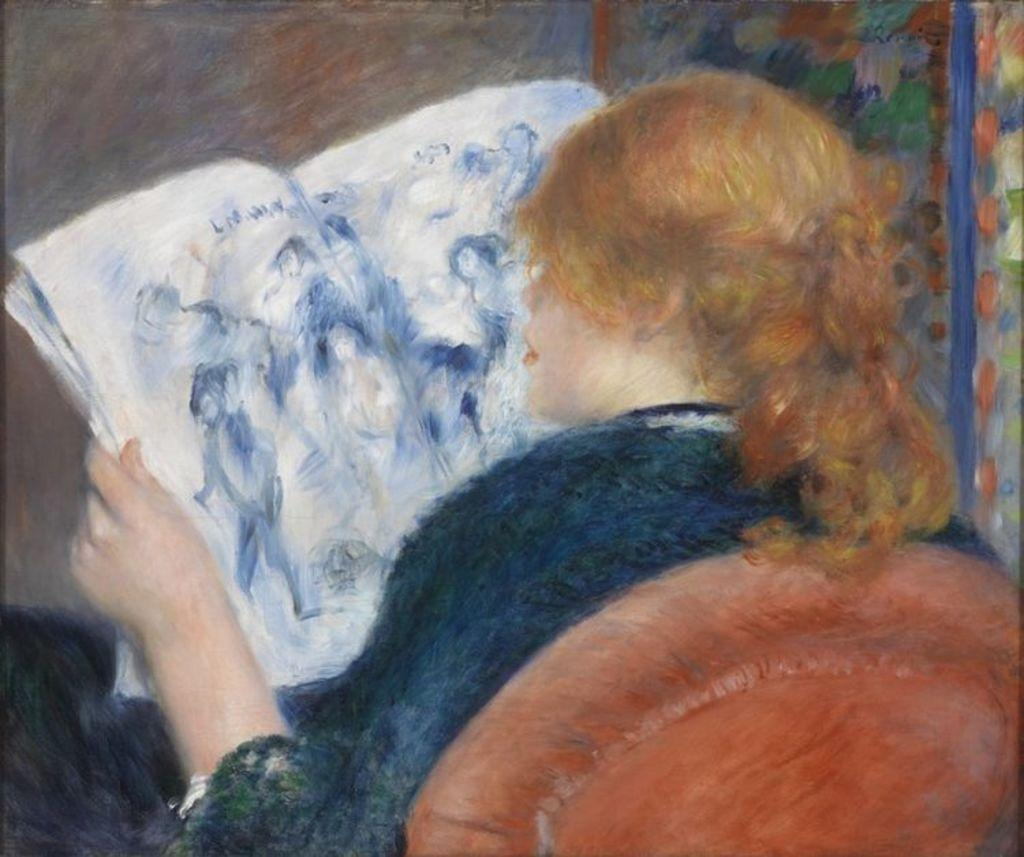What is the main subject of the image? There is a painting in the image. What is the painting depicting? The painting depicts a person sitting on a chair. What is the person in the painting holding? The person in the painting is holding a book. What type of thumb can be seen in the painting? There is no thumb visible in the painting; it depicts a person sitting on a chair and holding a book. 